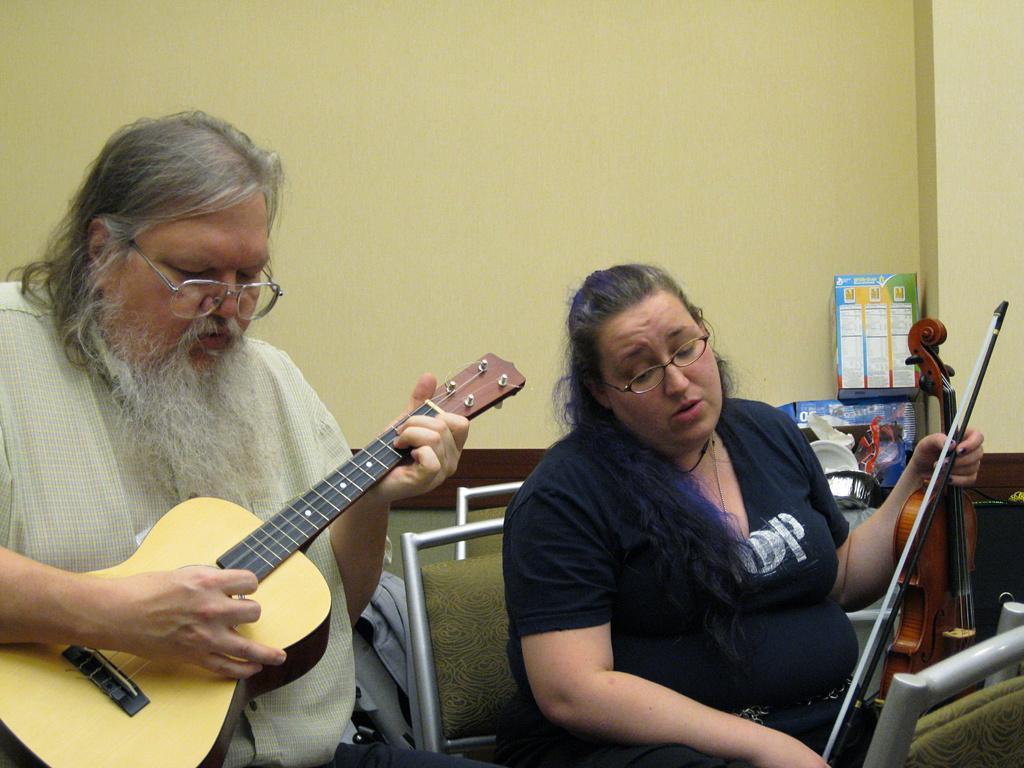Describe this image in one or two sentences. A guy to the left side of the image is playing guitar and a lady is playing violin on the other side. In the background we find a box named MMM and beneath it there are few objects. 